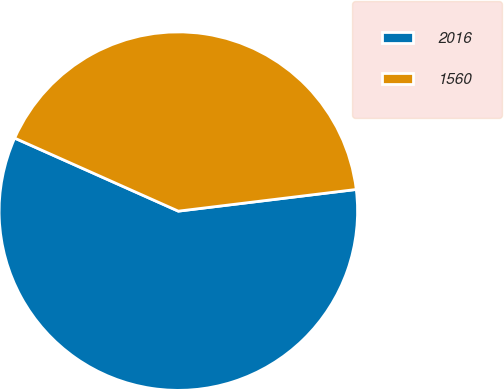Convert chart. <chart><loc_0><loc_0><loc_500><loc_500><pie_chart><fcel>2016<fcel>1560<nl><fcel>58.61%<fcel>41.39%<nl></chart> 